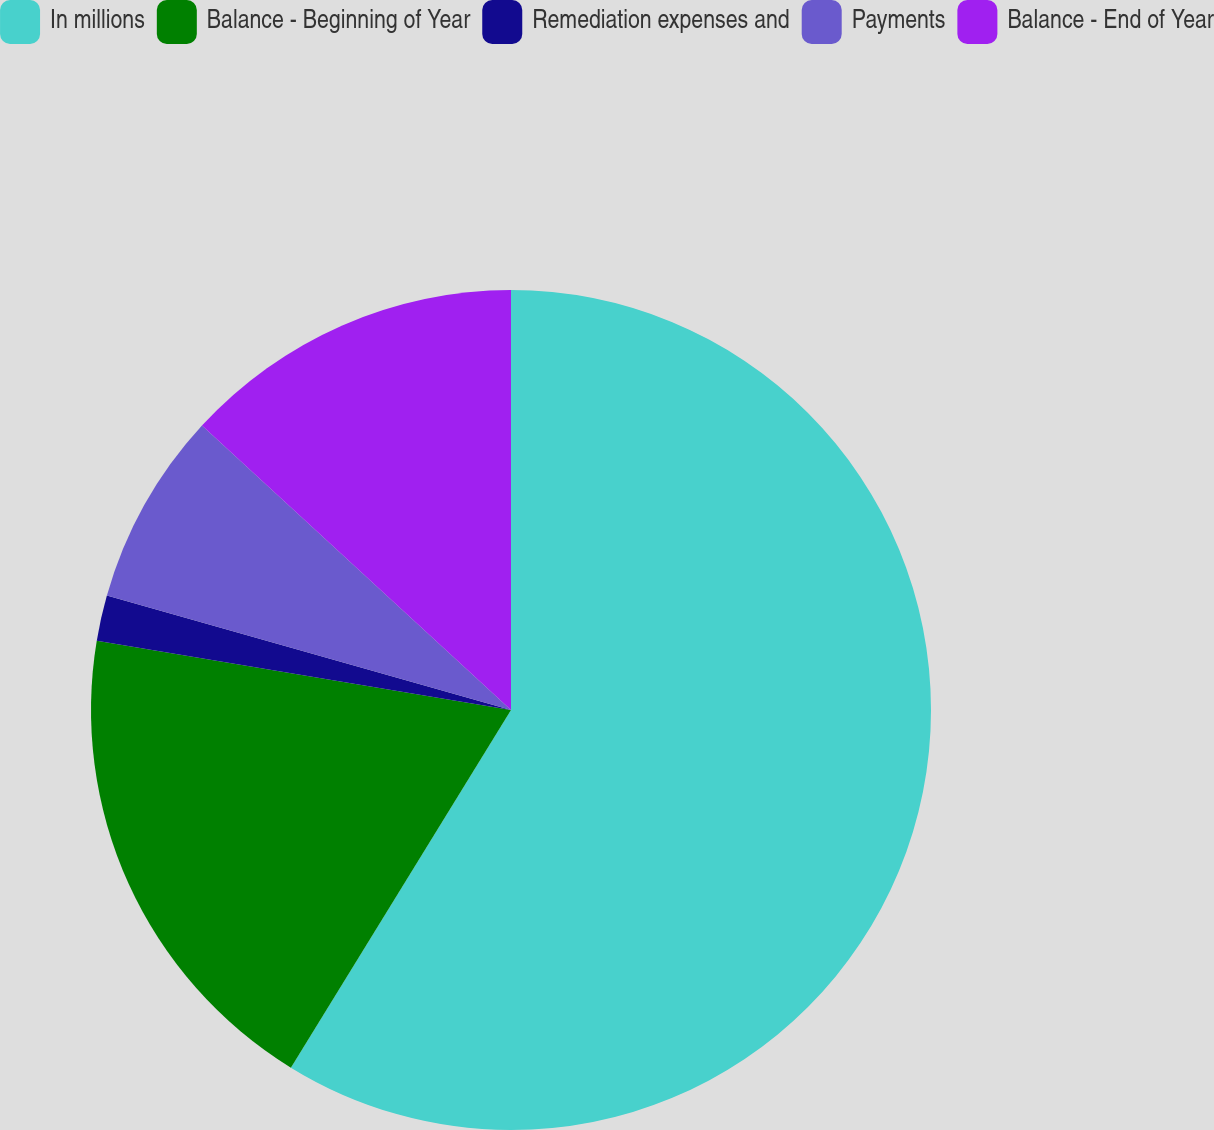<chart> <loc_0><loc_0><loc_500><loc_500><pie_chart><fcel>In millions<fcel>Balance - Beginning of Year<fcel>Remediation expenses and<fcel>Payments<fcel>Balance - End of Year<nl><fcel>58.78%<fcel>18.86%<fcel>1.75%<fcel>7.45%<fcel>13.16%<nl></chart> 